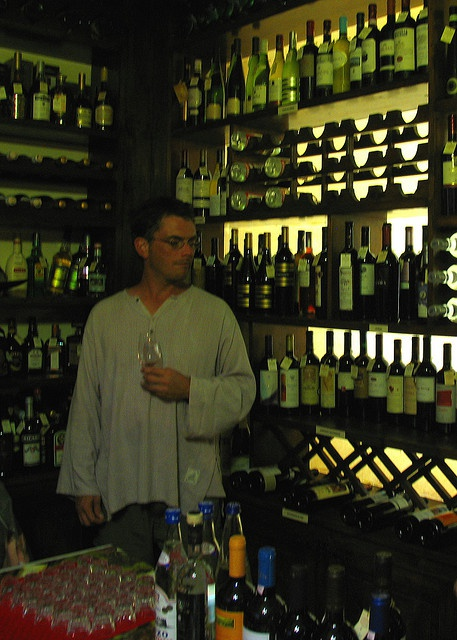Describe the objects in this image and their specific colors. I can see bottle in black, darkgreen, and olive tones, people in black, darkgreen, gray, and maroon tones, bottle in black, olive, maroon, and gray tones, bottle in black, darkgreen, and maroon tones, and bottle in black, darkgreen, and olive tones in this image. 